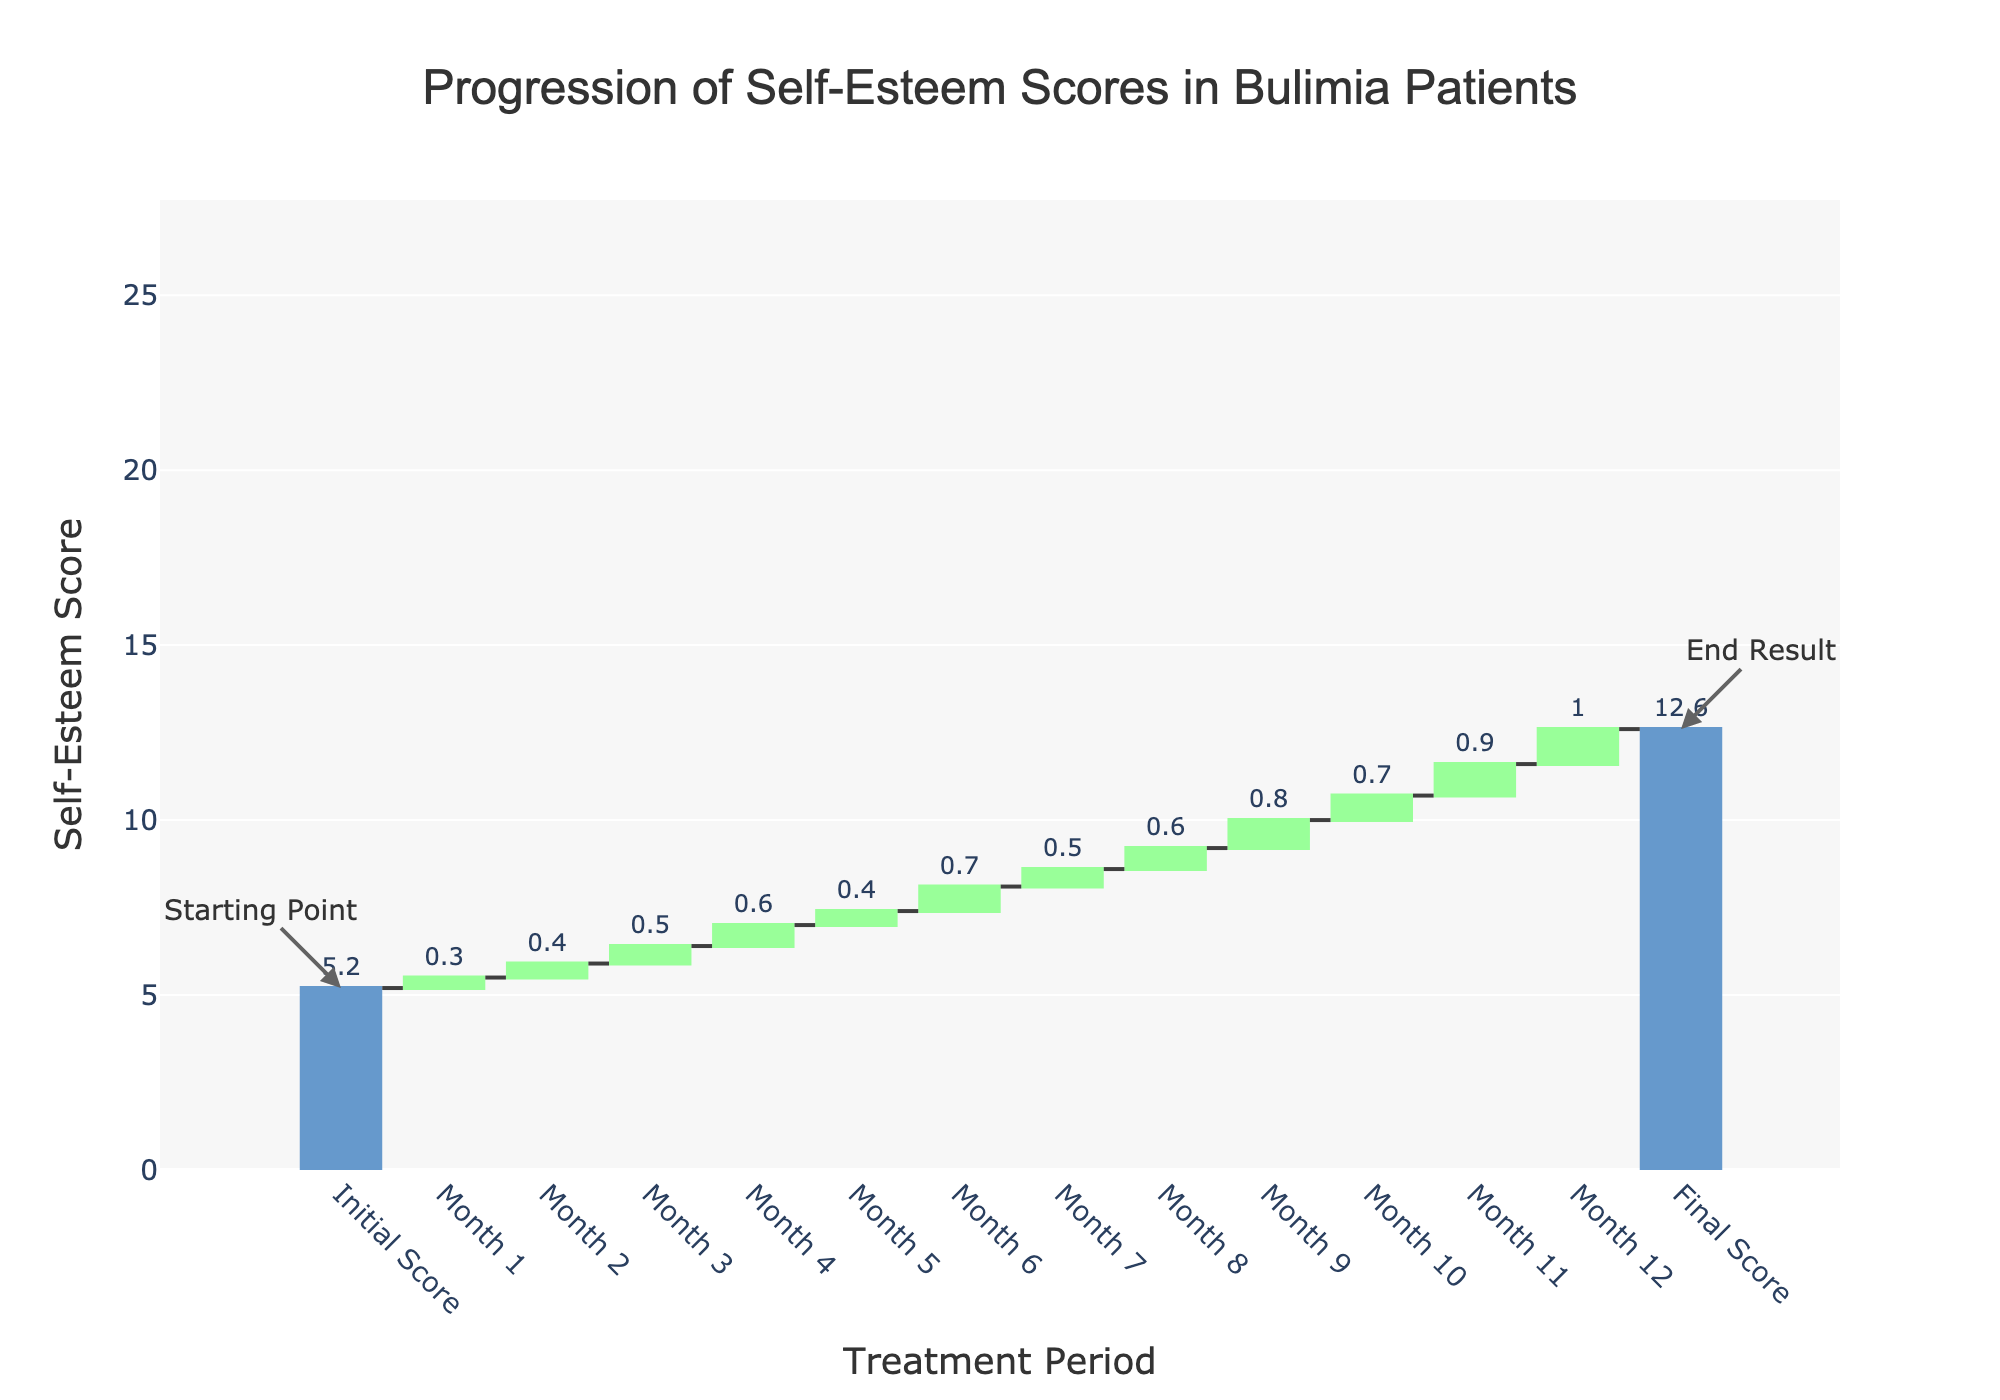What is the initial self-esteem score of the patients? The initial self-esteem score is indicated by the first bar labeled 'Initial Score'.
Answer: 5.2 What is the final self-esteem score after 12 months of treatment? The final self-esteem score is indicated by the 'Final Score' bar at the end of the chart.
Answer: 12.6 How much did the self-esteem score change from the initial score to the final score? By looking at the difference between the 'Initial Score' bar and the 'Final Score' bar, the change is calculated as 12.6 - 5.2.
Answer: 7.4 Which month showed the greatest increase in self-esteem score? By examining the heights of the bars corresponding to each month, the bar for Month 11 has the greatest height (0.9).
Answer: Month 11 Did any of the months show a decrease in self-esteem scores? In the waterfall chart, all bars corresponding to each month are colored green, indicating they are all increasing and none are decreasing.
Answer: No How much did the self-esteem score increase in the first 6 months? The scores from Month 1 to Month 6 are added together: 0.3 + 0.4 + 0.5 + 0.6 + 0.4 + 0.7.
Answer: 2.9 Compare the increase in self-esteem in Month 3 and Month 4. Which one is higher? By comparing the heights of the bars for Month 3 (0.5) and Month 4 (0.6), we can see that Month 4 has a higher value.
Answer: Month 4 What is the total increase in self-esteem score from Month 7 to Month 12? By summing the values from Month 7 to Month 12: 0.5 + 0.6 + 0.8 + 0.7 + 0.9 + 1.0.
Answer: 4.5 What is the average monthly increase in self-esteem score over the 12-month period? The total increase is the difference between initial and final scores (7.4), divided by the number of months (12).
Answer: 0.62 Was the increase in self-esteem score consistent throughout the 12 months? By observing the waterfall chart, there are variations in the monthly increases, indicating that the increase was not completely consistent.
Answer: No 